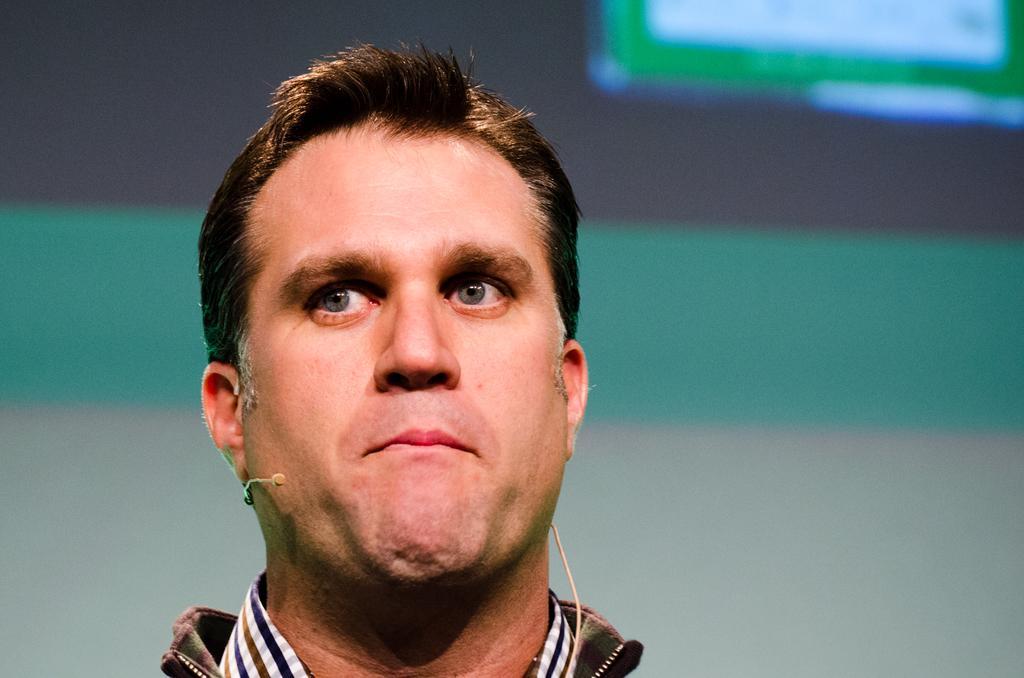Describe this image in one or two sentences. In the foreground of the image we can see a person wearing a dress and a microphone. In the background, we can see the screen. 